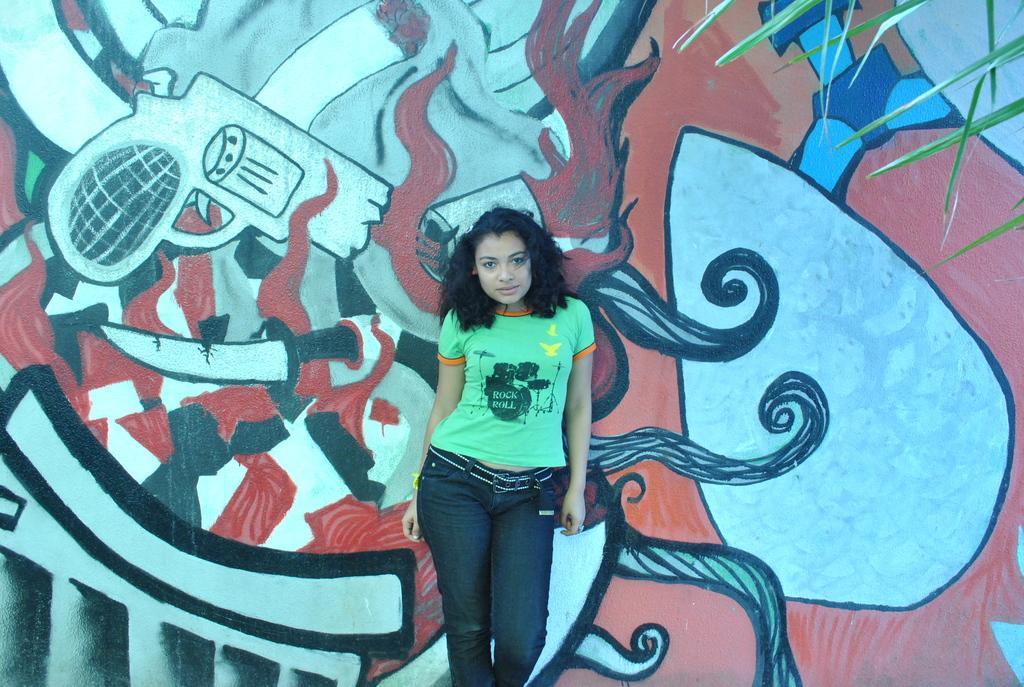Can you describe this image briefly? In the center of the image, we can see a lady standing and in the background, there is a painting on the wall and we can see a tree. 